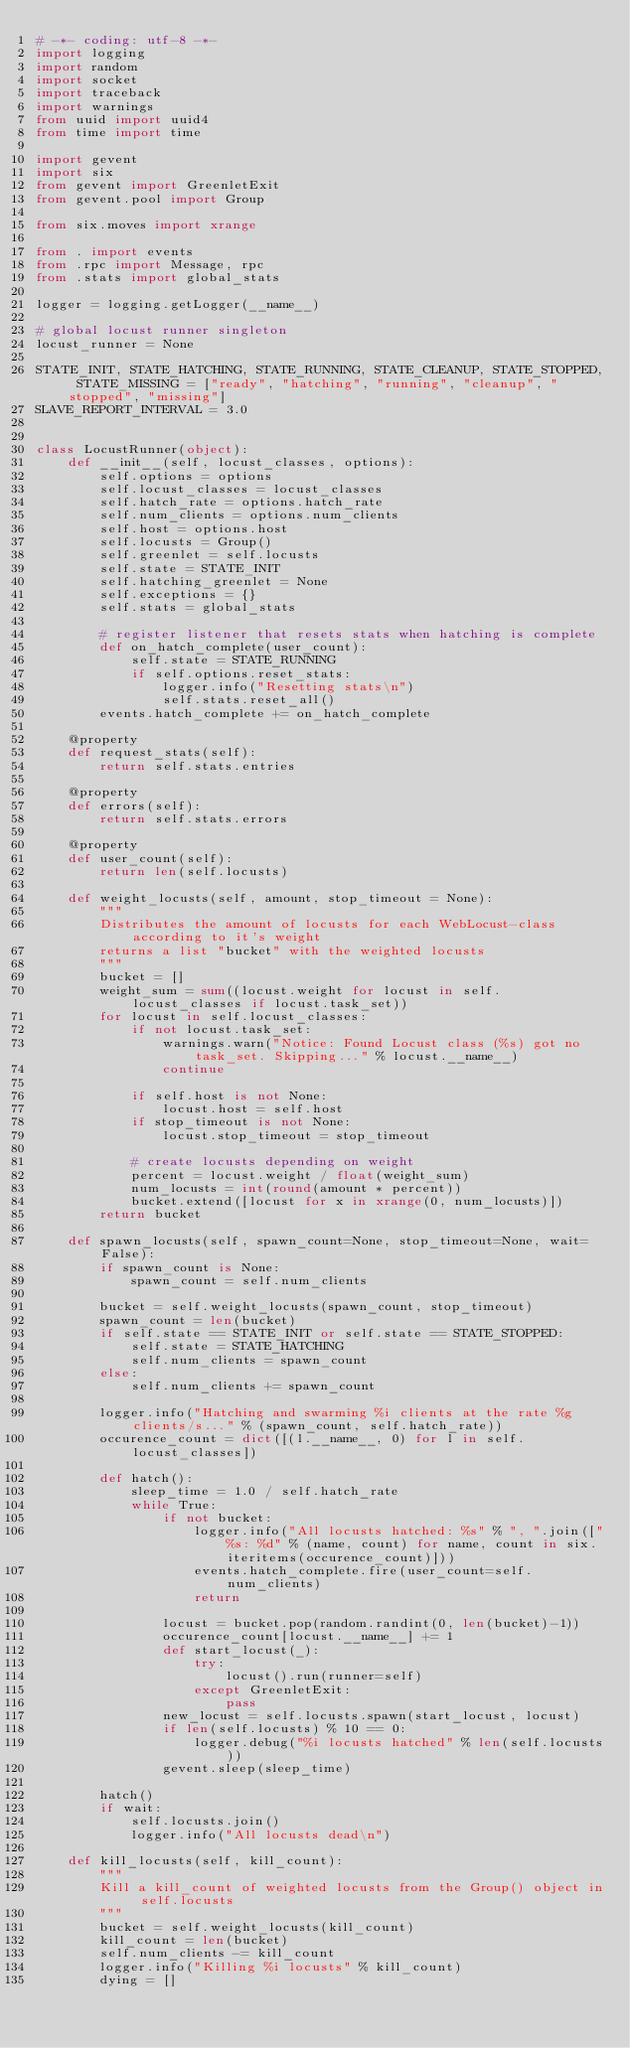Convert code to text. <code><loc_0><loc_0><loc_500><loc_500><_Python_># -*- coding: utf-8 -*-
import logging
import random
import socket
import traceback
import warnings
from uuid import uuid4
from time import time

import gevent
import six
from gevent import GreenletExit
from gevent.pool import Group

from six.moves import xrange

from . import events
from .rpc import Message, rpc
from .stats import global_stats

logger = logging.getLogger(__name__)

# global locust runner singleton
locust_runner = None

STATE_INIT, STATE_HATCHING, STATE_RUNNING, STATE_CLEANUP, STATE_STOPPED, STATE_MISSING = ["ready", "hatching", "running", "cleanup", "stopped", "missing"]
SLAVE_REPORT_INTERVAL = 3.0


class LocustRunner(object):
    def __init__(self, locust_classes, options):
        self.options = options
        self.locust_classes = locust_classes
        self.hatch_rate = options.hatch_rate
        self.num_clients = options.num_clients
        self.host = options.host
        self.locusts = Group()
        self.greenlet = self.locusts
        self.state = STATE_INIT
        self.hatching_greenlet = None
        self.exceptions = {}
        self.stats = global_stats
        
        # register listener that resets stats when hatching is complete
        def on_hatch_complete(user_count):
            self.state = STATE_RUNNING
            if self.options.reset_stats:
                logger.info("Resetting stats\n")
                self.stats.reset_all()
        events.hatch_complete += on_hatch_complete

    @property
    def request_stats(self):
        return self.stats.entries
    
    @property
    def errors(self):
        return self.stats.errors
    
    @property
    def user_count(self):
        return len(self.locusts)

    def weight_locusts(self, amount, stop_timeout = None):
        """
        Distributes the amount of locusts for each WebLocust-class according to it's weight
        returns a list "bucket" with the weighted locusts
        """
        bucket = []
        weight_sum = sum((locust.weight for locust in self.locust_classes if locust.task_set))
        for locust in self.locust_classes:
            if not locust.task_set:
                warnings.warn("Notice: Found Locust class (%s) got no task_set. Skipping..." % locust.__name__)
                continue

            if self.host is not None:
                locust.host = self.host
            if stop_timeout is not None:
                locust.stop_timeout = stop_timeout

            # create locusts depending on weight
            percent = locust.weight / float(weight_sum)
            num_locusts = int(round(amount * percent))
            bucket.extend([locust for x in xrange(0, num_locusts)])
        return bucket

    def spawn_locusts(self, spawn_count=None, stop_timeout=None, wait=False):
        if spawn_count is None:
            spawn_count = self.num_clients

        bucket = self.weight_locusts(spawn_count, stop_timeout)
        spawn_count = len(bucket)
        if self.state == STATE_INIT or self.state == STATE_STOPPED:
            self.state = STATE_HATCHING
            self.num_clients = spawn_count
        else:
            self.num_clients += spawn_count

        logger.info("Hatching and swarming %i clients at the rate %g clients/s..." % (spawn_count, self.hatch_rate))
        occurence_count = dict([(l.__name__, 0) for l in self.locust_classes])
        
        def hatch():
            sleep_time = 1.0 / self.hatch_rate
            while True:
                if not bucket:
                    logger.info("All locusts hatched: %s" % ", ".join(["%s: %d" % (name, count) for name, count in six.iteritems(occurence_count)]))
                    events.hatch_complete.fire(user_count=self.num_clients)
                    return

                locust = bucket.pop(random.randint(0, len(bucket)-1))
                occurence_count[locust.__name__] += 1
                def start_locust(_):
                    try:
                        locust().run(runner=self)
                    except GreenletExit:
                        pass
                new_locust = self.locusts.spawn(start_locust, locust)
                if len(self.locusts) % 10 == 0:
                    logger.debug("%i locusts hatched" % len(self.locusts))
                gevent.sleep(sleep_time)
        
        hatch()
        if wait:
            self.locusts.join()
            logger.info("All locusts dead\n")

    def kill_locusts(self, kill_count):
        """
        Kill a kill_count of weighted locusts from the Group() object in self.locusts
        """
        bucket = self.weight_locusts(kill_count)
        kill_count = len(bucket)
        self.num_clients -= kill_count
        logger.info("Killing %i locusts" % kill_count)
        dying = []</code> 